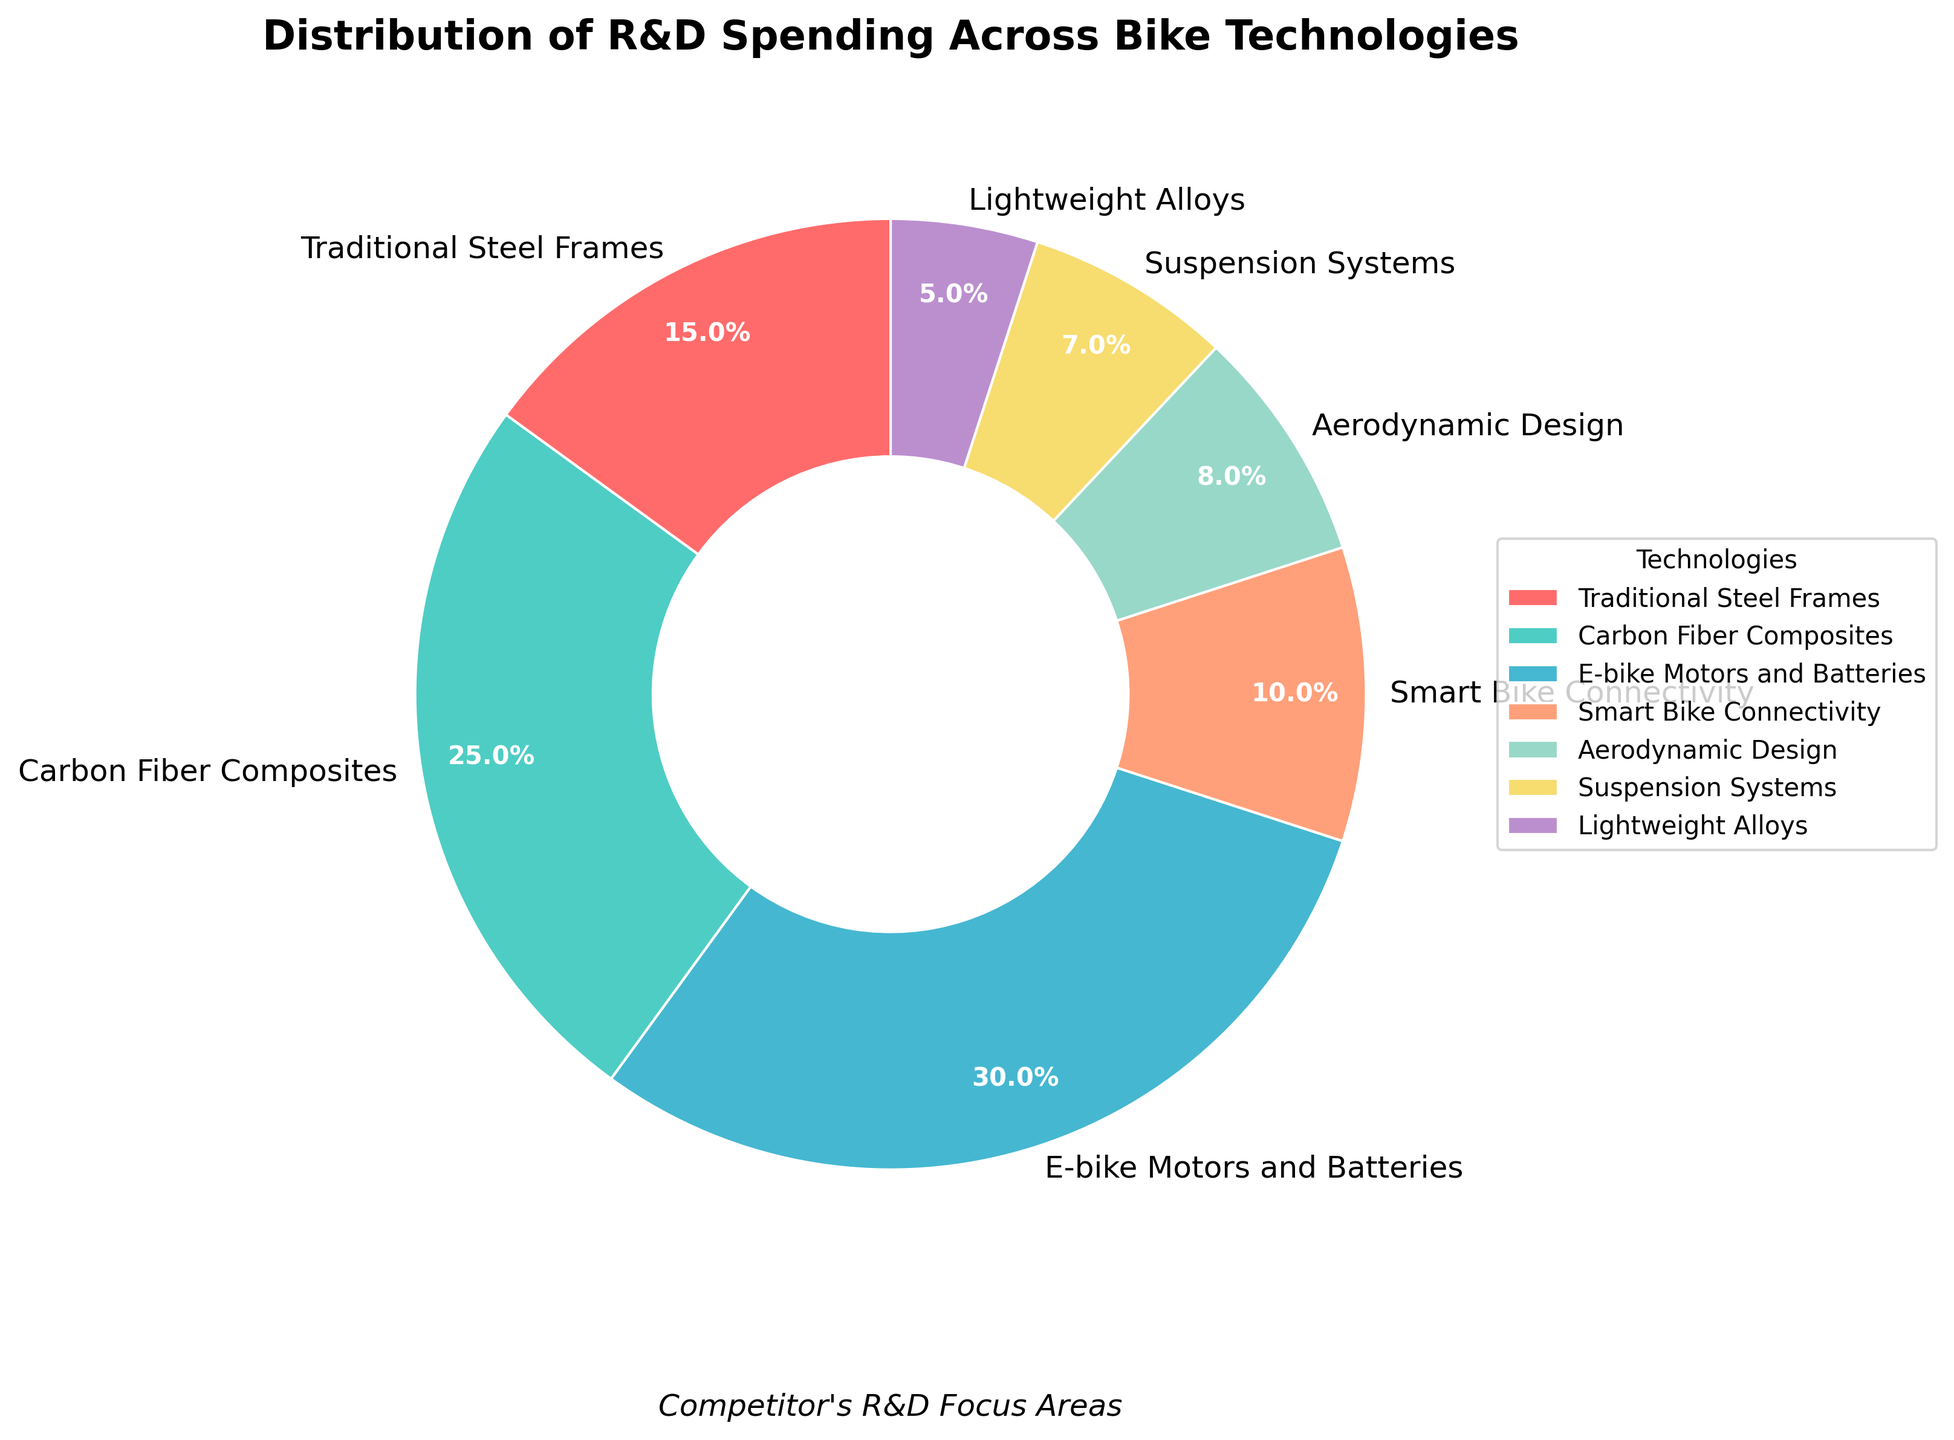What percentage of R&D spending is allocated to E-bike Motors and Batteries? The part of the pie chart labeled "E-bike Motors and Batteries" shows the percentage directly.
Answer: 30% Which technology receives the least amount of R&D spending? The technology with the smallest section of the pie chart is labeled "Lightweight Alloys."
Answer: Lightweight Alloys Compare the R&D spending on Carbon Fiber Composites to that on Traditional Steel Frames? The pie chart shows that Carbon Fiber Composites have 25% while Traditional Steel Frames have 15%.
Answer: Carbon Fiber Composites receive 10% more spending What is the combined percentage of R&D spending for Aerodynamic Design and Suspension Systems? Add the percentages for Aerodynamic Design (8%) and Suspension Systems (7%) from the pie chart.
Answer: 15% Are Smart Bike Connectivity and Lightweight Alloys combined R&D spending greater than that of Traditional Steel Frames? Add Smart Bike Connectivity (10%) and Lightweight Alloys (5%), and compare the sum (15%) against Traditional Steel Frames (15%).
Answer: They are equal What technology uses over a quarter of the R&D spending? Identify the technology with more than 25% from the pie chart sectors. None exceed 25%, but E-bike Motors and Batteries is 30%.
Answer: E-bike Motors and Batteries How does the R&D spending on Suspension Systems compare to that on Smart Bike Connectivity? The pie chart shows Suspension Systems have 7%, while Smart Bike Connectivity has 10%.
Answer: Smart Bike Connectivity gets 3% more What are the three technologies with the highest R&D spending? Observe the largest sectors visually identified in the pie chart.
Answer: E-bike Motors and Batteries, Carbon Fiber Composites, Traditional Steel Frames Calculate the difference in R&D spending between the highest and lowest funded technologies. The highest is E-bike Motors and Batteries at 30% and the lowest is Lightweight Alloys at 5%.
Answer: 25% If the R&D spending for Carbon Fiber Composites and Aerodynamic Design is combined, what fraction do they represent of the total R&D budget? Carbon Fiber Composites is 25% and Aerodynamic Design is 8%. Their sum (33%) represents 33/100 of the budget.
Answer: 0.33 or 33% 